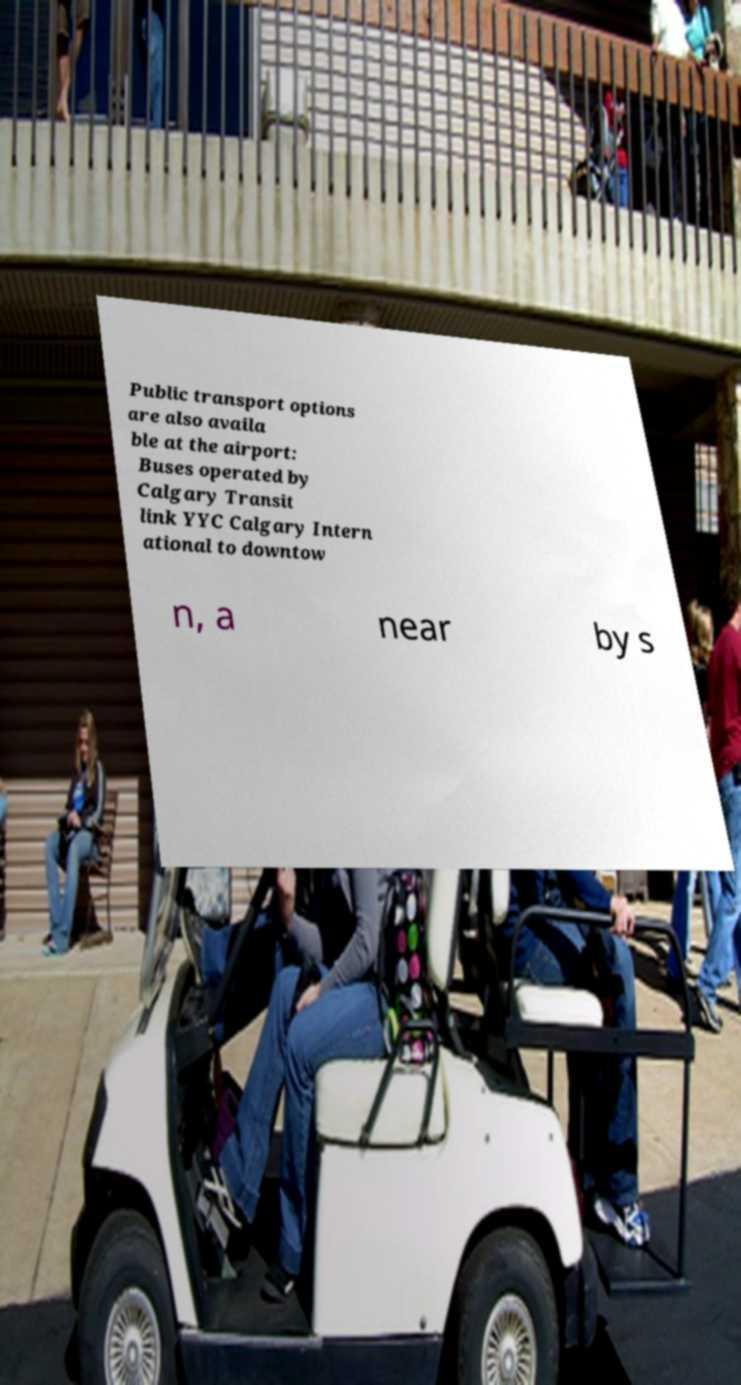For documentation purposes, I need the text within this image transcribed. Could you provide that? Public transport options are also availa ble at the airport: Buses operated by Calgary Transit link YYC Calgary Intern ational to downtow n, a near by s 